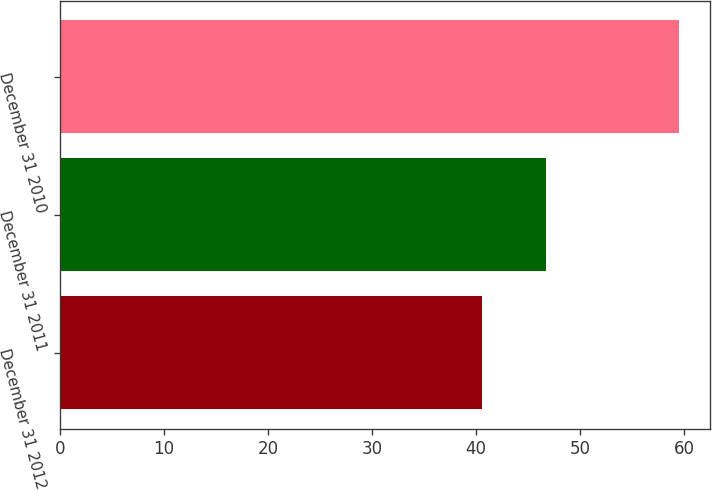<chart> <loc_0><loc_0><loc_500><loc_500><bar_chart><fcel>December 31 2012<fcel>December 31 2011<fcel>December 31 2010<nl><fcel>40.6<fcel>46.7<fcel>59.5<nl></chart> 